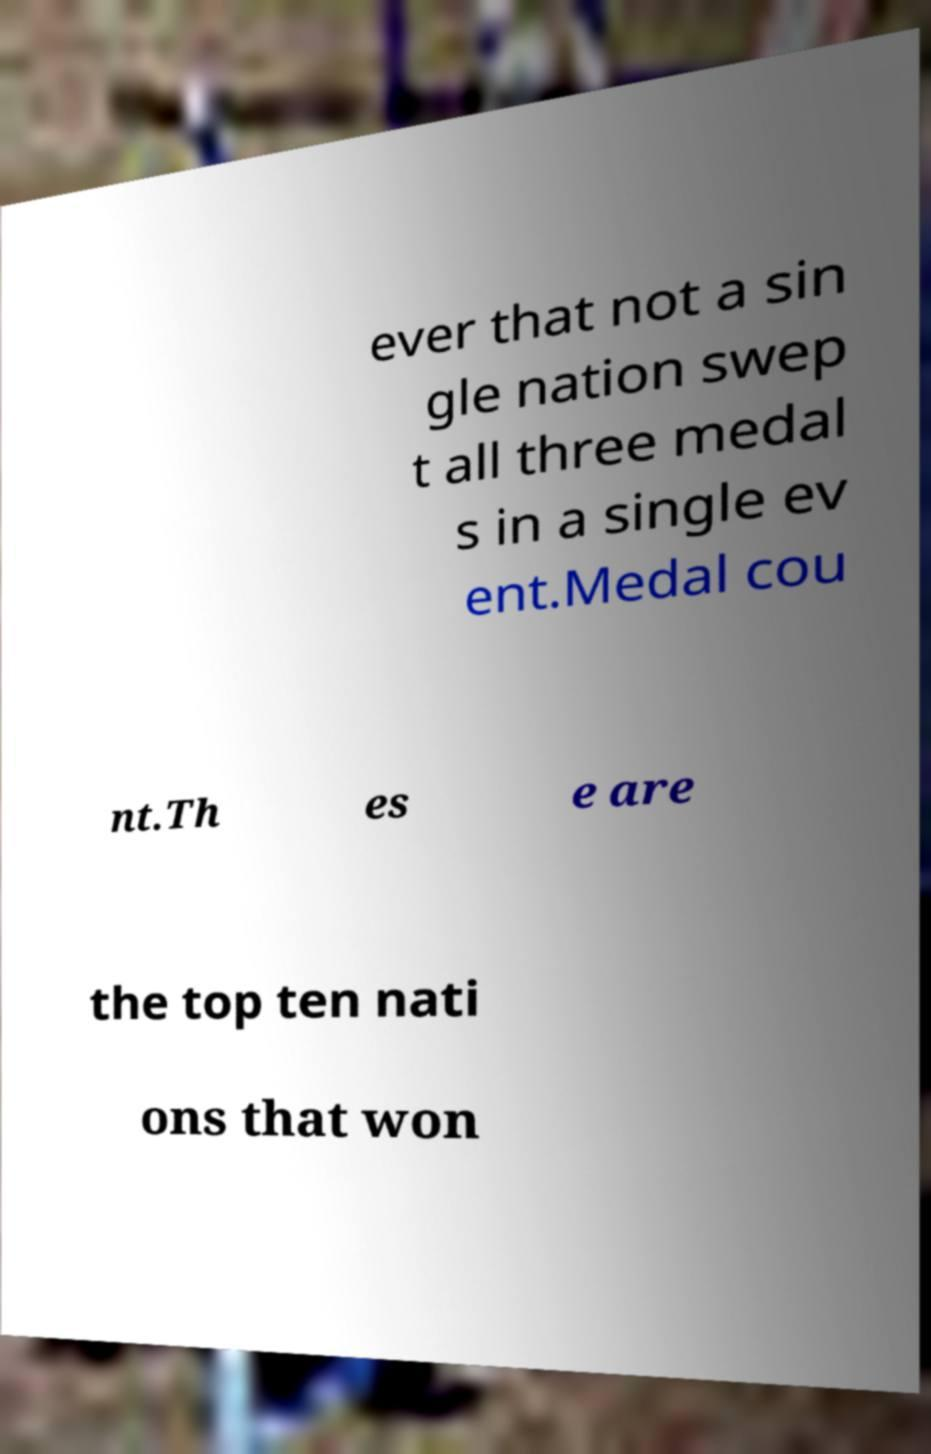Could you extract and type out the text from this image? ever that not a sin gle nation swep t all three medal s in a single ev ent.Medal cou nt.Th es e are the top ten nati ons that won 